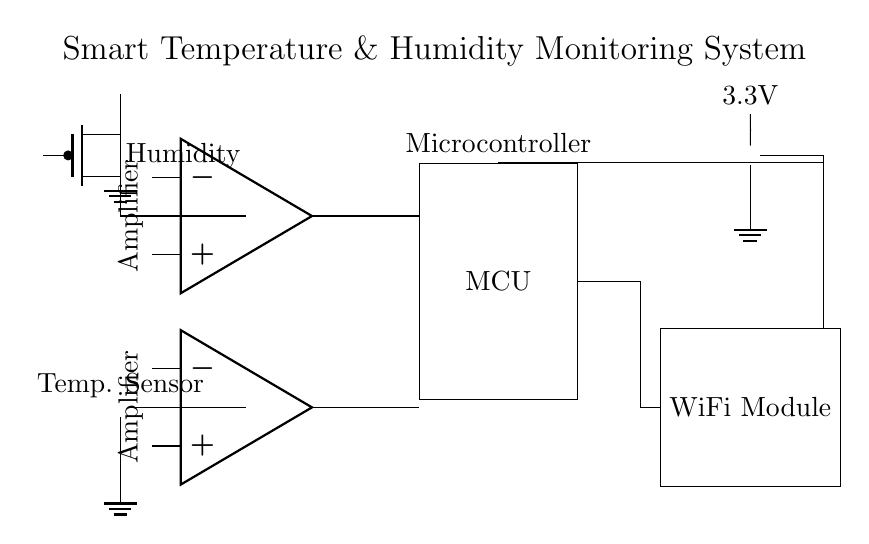What type of sensors are included in this circuit? The circuit includes a temperature sensor and a humidity sensor, clearly indicated by their respective symbols. Each sensor is connected to an operational amplifier, showing their role in the measuring process.
Answer: temperature and humidity sensors What is the power supply voltage for this circuit? The circuit diagram shows a battery labeled with a voltage of 3.3V. This value is directly associated with the power supply used to power the various components in the circuit.
Answer: 3.3V How are the sensors connected to the microcontroller? The outputs of both the temperature sensor and the humidity sensor pass through operational amplifiers before connecting to the microcontroller. They use connecting lines that indicate an output to the microcontroller's corresponding inputs.
Answer: through operational amplifiers What is the primary function of the operational amplifiers in this circuit? The operational amplifiers amplify the signals received from the sensors. This is crucial as sensors typically provide low signal levels, and amplification is necessary for proper analysis by the microcontroller, which can process these enhanced signals.
Answer: signal amplification Which components are responsible for wireless communication? The wire connections leading away from the microcontroller to a separate component indicate that the WiFi module is responsible for wireless communication, allowing data transmission to external devices or networks.
Answer: WiFi module What are the connections showing from the battery to other components? The battery connection flows directly to both the microcontroller and the WiFi module, providing the same 3.3V, indicating that they rely on the same power source. The layout shows parallel connections to both components.
Answer: parallel connections 